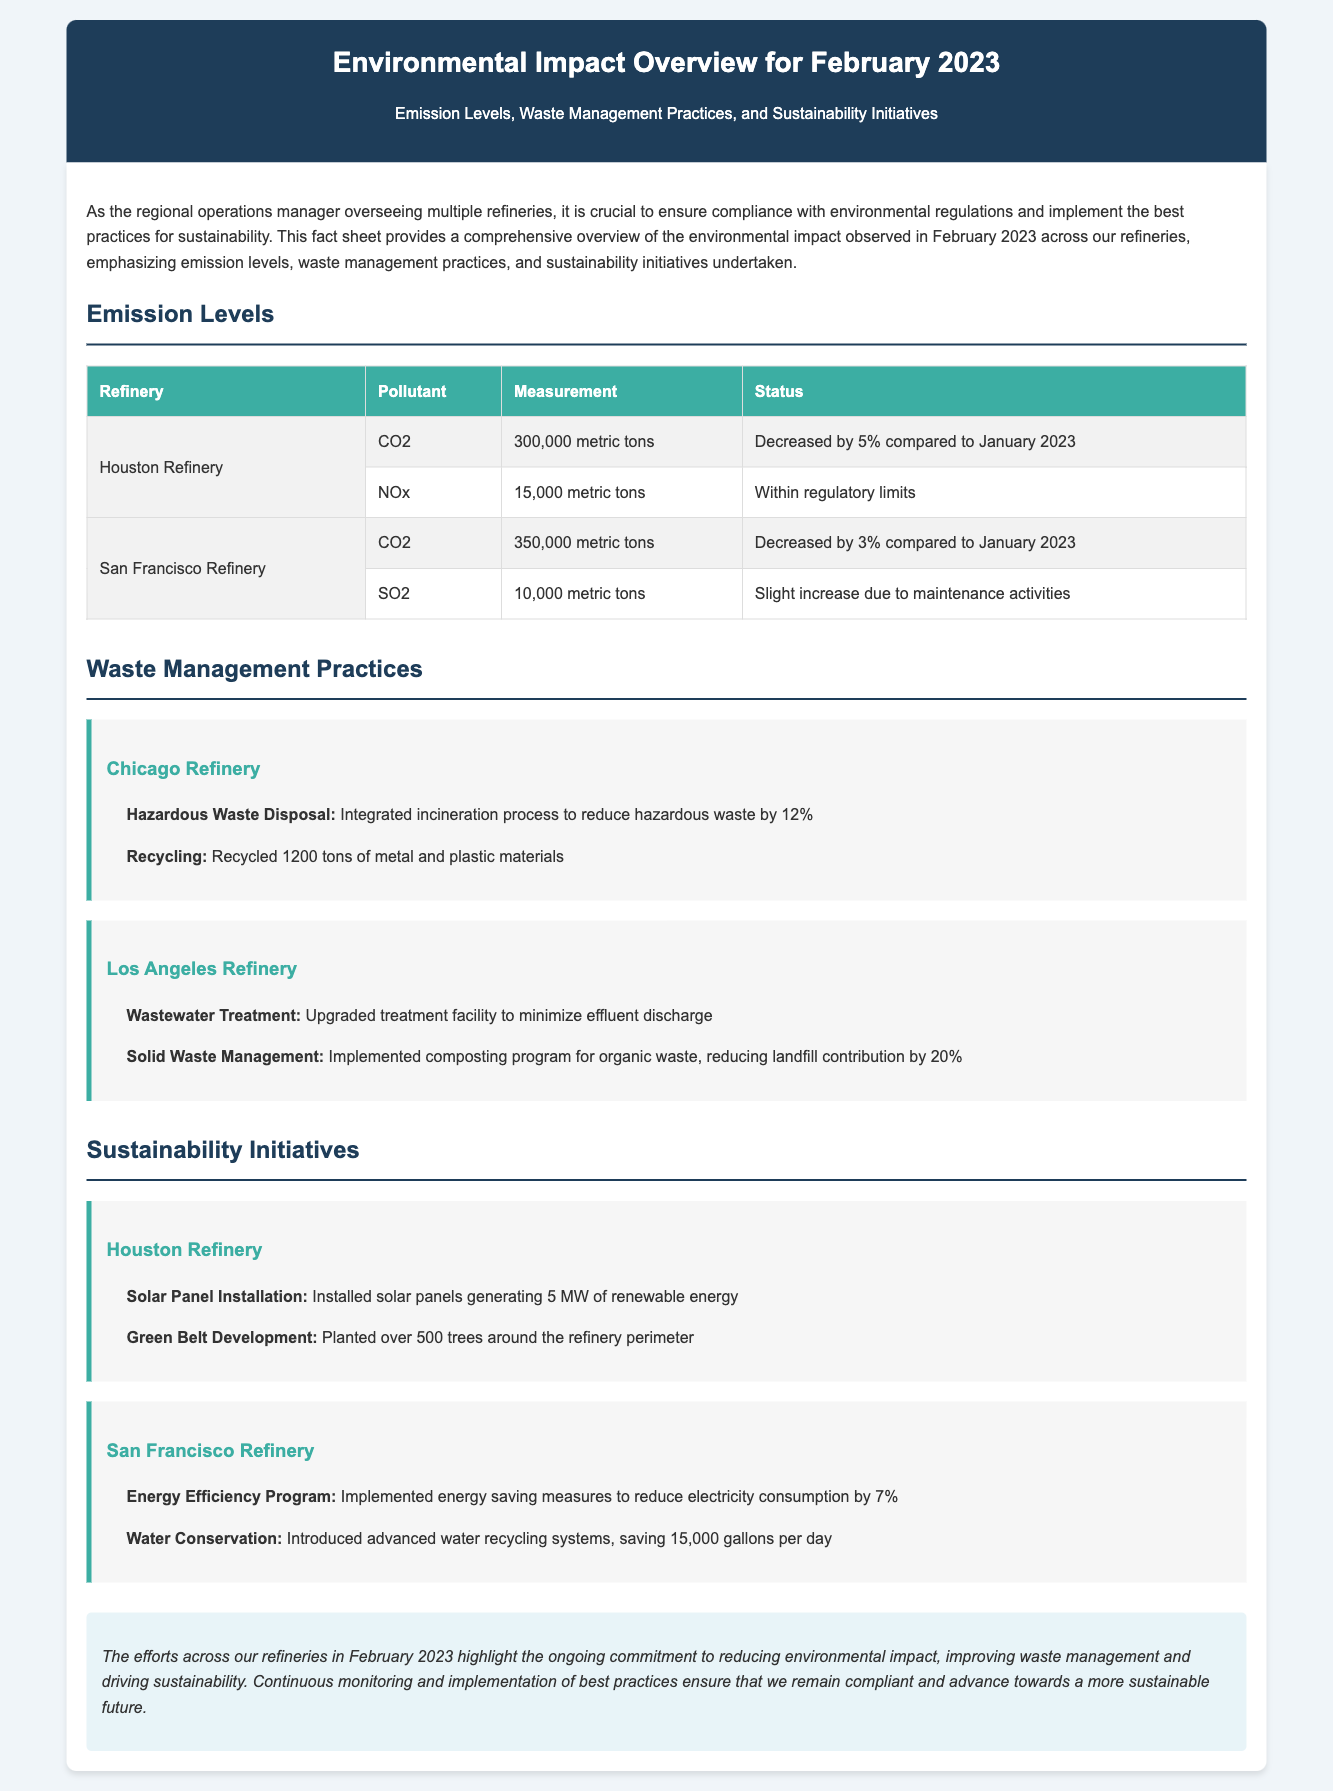What were the CO2 emission levels for the Houston Refinery? The CO2 emission level for the Houston Refinery is 300,000 metric tons, as noted in the emissions table.
Answer: 300,000 metric tons What was the percentage decrease of CO2 emissions at the Houston Refinery compared to January 2023? The document states that CO2 emissions at the Houston Refinery decreased by 5% compared to January 2023.
Answer: 5% What innovative waste management practice was implemented at the Los Angeles Refinery? The Los Angeles Refinery implemented a composting program for organic waste, which is mentioned in the waste management section.
Answer: Composting program How many trees were planted around the Houston Refinery perimeter? The document specifies that over 500 trees were planted around the perimeter of the Houston Refinery as part of their sustainability initiatives.
Answer: Over 500 trees What was the amount of SO2 emissions for the San Francisco Refinery? According to the emissions table, the SO2 emission level for the San Francisco Refinery is 10,000 metric tons.
Answer: 10,000 metric tons Which refinery had a hazardous waste disposal improvement of 12%? The Chicago Refinery integrated an incineration process that reduced hazardous waste by 12%, as stated in the waste management practices section.
Answer: Chicago Refinery What is the total renewable energy generation capacity from solar panels at the Houston Refinery? The document indicates that the solar panel installation at the Houston Refinery generates 5 MW of renewable energy.
Answer: 5 MW What initiative at the San Francisco Refinery helps save 15,000 gallons of water per day? The San Francisco Refinery introduced advanced water recycling systems, which is mentioned in the sustainability initiatives section.
Answer: Advanced water recycling systems 